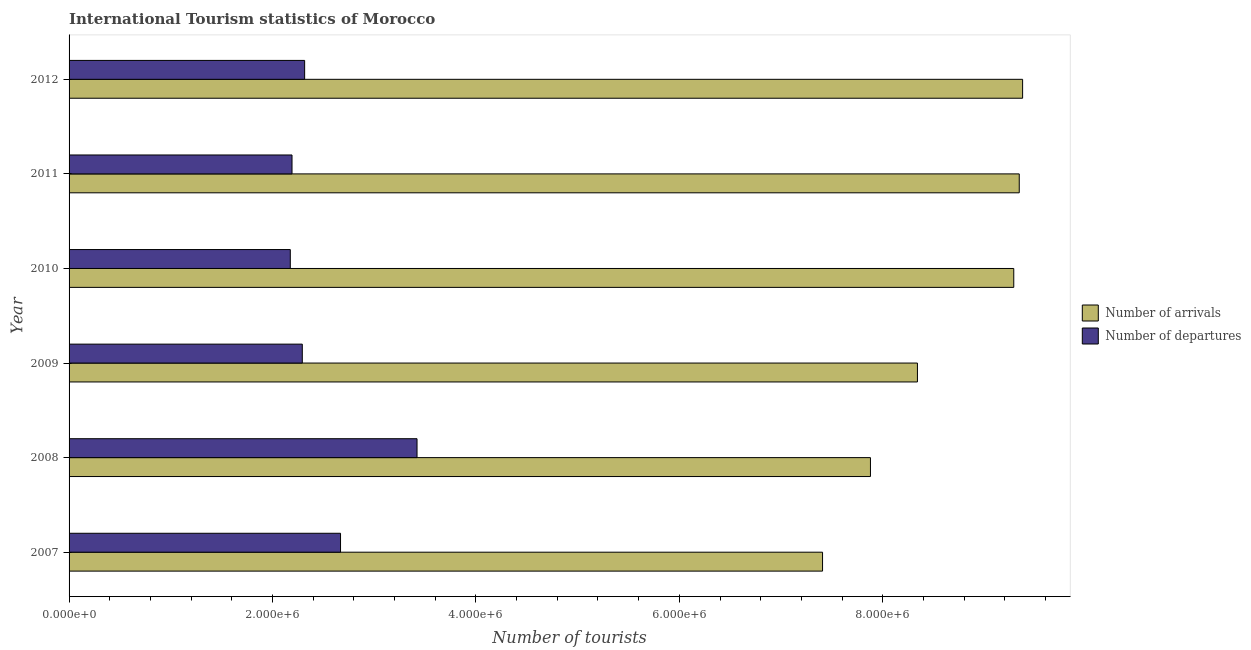How many different coloured bars are there?
Keep it short and to the point. 2. Are the number of bars per tick equal to the number of legend labels?
Your response must be concise. Yes. How many bars are there on the 1st tick from the top?
Your response must be concise. 2. How many bars are there on the 6th tick from the bottom?
Provide a succinct answer. 2. In how many cases, is the number of bars for a given year not equal to the number of legend labels?
Offer a terse response. 0. What is the number of tourist departures in 2012?
Your answer should be very brief. 2.32e+06. Across all years, what is the maximum number of tourist arrivals?
Ensure brevity in your answer.  9.38e+06. Across all years, what is the minimum number of tourist arrivals?
Your answer should be very brief. 7.41e+06. In which year was the number of tourist arrivals maximum?
Keep it short and to the point. 2012. In which year was the number of tourist departures minimum?
Your answer should be very brief. 2010. What is the total number of tourist arrivals in the graph?
Your answer should be compact. 5.16e+07. What is the difference between the number of tourist arrivals in 2009 and that in 2011?
Ensure brevity in your answer.  -1.00e+06. What is the difference between the number of tourist arrivals in 2007 and the number of tourist departures in 2012?
Offer a terse response. 5.09e+06. What is the average number of tourist arrivals per year?
Make the answer very short. 8.61e+06. In the year 2009, what is the difference between the number of tourist departures and number of tourist arrivals?
Give a very brief answer. -6.05e+06. What is the ratio of the number of tourist arrivals in 2010 to that in 2011?
Give a very brief answer. 0.99. What is the difference between the highest and the second highest number of tourist arrivals?
Your answer should be very brief. 3.30e+04. What is the difference between the highest and the lowest number of tourist departures?
Ensure brevity in your answer.  1.25e+06. What does the 1st bar from the top in 2011 represents?
Make the answer very short. Number of departures. What does the 2nd bar from the bottom in 2008 represents?
Ensure brevity in your answer.  Number of departures. How many bars are there?
Your answer should be very brief. 12. Are all the bars in the graph horizontal?
Give a very brief answer. Yes. How many years are there in the graph?
Provide a succinct answer. 6. What is the difference between two consecutive major ticks on the X-axis?
Your answer should be very brief. 2.00e+06. Are the values on the major ticks of X-axis written in scientific E-notation?
Ensure brevity in your answer.  Yes. Does the graph contain grids?
Provide a succinct answer. No. What is the title of the graph?
Offer a terse response. International Tourism statistics of Morocco. Does "Automatic Teller Machines" appear as one of the legend labels in the graph?
Your response must be concise. No. What is the label or title of the X-axis?
Keep it short and to the point. Number of tourists. What is the label or title of the Y-axis?
Your answer should be compact. Year. What is the Number of tourists in Number of arrivals in 2007?
Your answer should be very brief. 7.41e+06. What is the Number of tourists of Number of departures in 2007?
Make the answer very short. 2.67e+06. What is the Number of tourists in Number of arrivals in 2008?
Offer a very short reply. 7.88e+06. What is the Number of tourists in Number of departures in 2008?
Ensure brevity in your answer.  3.42e+06. What is the Number of tourists in Number of arrivals in 2009?
Give a very brief answer. 8.34e+06. What is the Number of tourists in Number of departures in 2009?
Offer a terse response. 2.29e+06. What is the Number of tourists in Number of arrivals in 2010?
Offer a terse response. 9.29e+06. What is the Number of tourists of Number of departures in 2010?
Your response must be concise. 2.18e+06. What is the Number of tourists of Number of arrivals in 2011?
Keep it short and to the point. 9.34e+06. What is the Number of tourists in Number of departures in 2011?
Provide a short and direct response. 2.19e+06. What is the Number of tourists in Number of arrivals in 2012?
Provide a short and direct response. 9.38e+06. What is the Number of tourists in Number of departures in 2012?
Keep it short and to the point. 2.32e+06. Across all years, what is the maximum Number of tourists of Number of arrivals?
Give a very brief answer. 9.38e+06. Across all years, what is the maximum Number of tourists of Number of departures?
Your response must be concise. 3.42e+06. Across all years, what is the minimum Number of tourists in Number of arrivals?
Keep it short and to the point. 7.41e+06. Across all years, what is the minimum Number of tourists of Number of departures?
Your answer should be very brief. 2.18e+06. What is the total Number of tourists in Number of arrivals in the graph?
Offer a very short reply. 5.16e+07. What is the total Number of tourists of Number of departures in the graph?
Keep it short and to the point. 1.51e+07. What is the difference between the Number of tourists of Number of arrivals in 2007 and that in 2008?
Your response must be concise. -4.71e+05. What is the difference between the Number of tourists in Number of departures in 2007 and that in 2008?
Make the answer very short. -7.52e+05. What is the difference between the Number of tourists in Number of arrivals in 2007 and that in 2009?
Make the answer very short. -9.33e+05. What is the difference between the Number of tourists of Number of departures in 2007 and that in 2009?
Offer a very short reply. 3.76e+05. What is the difference between the Number of tourists in Number of arrivals in 2007 and that in 2010?
Give a very brief answer. -1.88e+06. What is the difference between the Number of tourists of Number of departures in 2007 and that in 2010?
Give a very brief answer. 4.94e+05. What is the difference between the Number of tourists of Number of arrivals in 2007 and that in 2011?
Give a very brief answer. -1.93e+06. What is the difference between the Number of tourists in Number of departures in 2007 and that in 2011?
Your answer should be very brief. 4.77e+05. What is the difference between the Number of tourists in Number of arrivals in 2007 and that in 2012?
Provide a short and direct response. -1.97e+06. What is the difference between the Number of tourists of Number of departures in 2007 and that in 2012?
Ensure brevity in your answer.  3.53e+05. What is the difference between the Number of tourists in Number of arrivals in 2008 and that in 2009?
Provide a succinct answer. -4.62e+05. What is the difference between the Number of tourists in Number of departures in 2008 and that in 2009?
Your answer should be very brief. 1.13e+06. What is the difference between the Number of tourists of Number of arrivals in 2008 and that in 2010?
Ensure brevity in your answer.  -1.41e+06. What is the difference between the Number of tourists in Number of departures in 2008 and that in 2010?
Keep it short and to the point. 1.25e+06. What is the difference between the Number of tourists in Number of arrivals in 2008 and that in 2011?
Your response must be concise. -1.46e+06. What is the difference between the Number of tourists in Number of departures in 2008 and that in 2011?
Your answer should be compact. 1.23e+06. What is the difference between the Number of tourists of Number of arrivals in 2008 and that in 2012?
Offer a very short reply. -1.50e+06. What is the difference between the Number of tourists of Number of departures in 2008 and that in 2012?
Provide a succinct answer. 1.10e+06. What is the difference between the Number of tourists in Number of arrivals in 2009 and that in 2010?
Your answer should be compact. -9.47e+05. What is the difference between the Number of tourists of Number of departures in 2009 and that in 2010?
Make the answer very short. 1.18e+05. What is the difference between the Number of tourists of Number of arrivals in 2009 and that in 2011?
Make the answer very short. -1.00e+06. What is the difference between the Number of tourists in Number of departures in 2009 and that in 2011?
Offer a terse response. 1.01e+05. What is the difference between the Number of tourists in Number of arrivals in 2009 and that in 2012?
Your answer should be very brief. -1.03e+06. What is the difference between the Number of tourists in Number of departures in 2009 and that in 2012?
Your answer should be compact. -2.30e+04. What is the difference between the Number of tourists of Number of arrivals in 2010 and that in 2011?
Your answer should be compact. -5.40e+04. What is the difference between the Number of tourists in Number of departures in 2010 and that in 2011?
Your response must be concise. -1.70e+04. What is the difference between the Number of tourists of Number of arrivals in 2010 and that in 2012?
Make the answer very short. -8.70e+04. What is the difference between the Number of tourists of Number of departures in 2010 and that in 2012?
Provide a short and direct response. -1.41e+05. What is the difference between the Number of tourists in Number of arrivals in 2011 and that in 2012?
Give a very brief answer. -3.30e+04. What is the difference between the Number of tourists of Number of departures in 2011 and that in 2012?
Offer a very short reply. -1.24e+05. What is the difference between the Number of tourists in Number of arrivals in 2007 and the Number of tourists in Number of departures in 2008?
Offer a very short reply. 3.99e+06. What is the difference between the Number of tourists of Number of arrivals in 2007 and the Number of tourists of Number of departures in 2009?
Your response must be concise. 5.12e+06. What is the difference between the Number of tourists of Number of arrivals in 2007 and the Number of tourists of Number of departures in 2010?
Your response must be concise. 5.23e+06. What is the difference between the Number of tourists of Number of arrivals in 2007 and the Number of tourists of Number of departures in 2011?
Your answer should be compact. 5.22e+06. What is the difference between the Number of tourists of Number of arrivals in 2007 and the Number of tourists of Number of departures in 2012?
Offer a terse response. 5.09e+06. What is the difference between the Number of tourists in Number of arrivals in 2008 and the Number of tourists in Number of departures in 2009?
Your response must be concise. 5.59e+06. What is the difference between the Number of tourists in Number of arrivals in 2008 and the Number of tourists in Number of departures in 2010?
Make the answer very short. 5.70e+06. What is the difference between the Number of tourists in Number of arrivals in 2008 and the Number of tourists in Number of departures in 2011?
Your answer should be very brief. 5.69e+06. What is the difference between the Number of tourists in Number of arrivals in 2008 and the Number of tourists in Number of departures in 2012?
Your answer should be very brief. 5.56e+06. What is the difference between the Number of tourists in Number of arrivals in 2009 and the Number of tourists in Number of departures in 2010?
Your answer should be compact. 6.17e+06. What is the difference between the Number of tourists in Number of arrivals in 2009 and the Number of tourists in Number of departures in 2011?
Give a very brief answer. 6.15e+06. What is the difference between the Number of tourists in Number of arrivals in 2009 and the Number of tourists in Number of departures in 2012?
Give a very brief answer. 6.02e+06. What is the difference between the Number of tourists in Number of arrivals in 2010 and the Number of tourists in Number of departures in 2011?
Offer a very short reply. 7.10e+06. What is the difference between the Number of tourists in Number of arrivals in 2010 and the Number of tourists in Number of departures in 2012?
Offer a very short reply. 6.97e+06. What is the difference between the Number of tourists of Number of arrivals in 2011 and the Number of tourists of Number of departures in 2012?
Provide a succinct answer. 7.03e+06. What is the average Number of tourists of Number of arrivals per year?
Give a very brief answer. 8.61e+06. What is the average Number of tourists of Number of departures per year?
Your answer should be compact. 2.51e+06. In the year 2007, what is the difference between the Number of tourists in Number of arrivals and Number of tourists in Number of departures?
Ensure brevity in your answer.  4.74e+06. In the year 2008, what is the difference between the Number of tourists in Number of arrivals and Number of tourists in Number of departures?
Offer a very short reply. 4.46e+06. In the year 2009, what is the difference between the Number of tourists of Number of arrivals and Number of tourists of Number of departures?
Your answer should be compact. 6.05e+06. In the year 2010, what is the difference between the Number of tourists of Number of arrivals and Number of tourists of Number of departures?
Your answer should be compact. 7.11e+06. In the year 2011, what is the difference between the Number of tourists of Number of arrivals and Number of tourists of Number of departures?
Your answer should be compact. 7.15e+06. In the year 2012, what is the difference between the Number of tourists of Number of arrivals and Number of tourists of Number of departures?
Make the answer very short. 7.06e+06. What is the ratio of the Number of tourists of Number of arrivals in 2007 to that in 2008?
Offer a very short reply. 0.94. What is the ratio of the Number of tourists in Number of departures in 2007 to that in 2008?
Your response must be concise. 0.78. What is the ratio of the Number of tourists of Number of arrivals in 2007 to that in 2009?
Make the answer very short. 0.89. What is the ratio of the Number of tourists in Number of departures in 2007 to that in 2009?
Make the answer very short. 1.16. What is the ratio of the Number of tourists of Number of arrivals in 2007 to that in 2010?
Give a very brief answer. 0.8. What is the ratio of the Number of tourists in Number of departures in 2007 to that in 2010?
Provide a short and direct response. 1.23. What is the ratio of the Number of tourists of Number of arrivals in 2007 to that in 2011?
Offer a terse response. 0.79. What is the ratio of the Number of tourists of Number of departures in 2007 to that in 2011?
Your answer should be compact. 1.22. What is the ratio of the Number of tourists in Number of arrivals in 2007 to that in 2012?
Your response must be concise. 0.79. What is the ratio of the Number of tourists in Number of departures in 2007 to that in 2012?
Offer a terse response. 1.15. What is the ratio of the Number of tourists of Number of arrivals in 2008 to that in 2009?
Offer a terse response. 0.94. What is the ratio of the Number of tourists of Number of departures in 2008 to that in 2009?
Give a very brief answer. 1.49. What is the ratio of the Number of tourists in Number of arrivals in 2008 to that in 2010?
Offer a very short reply. 0.85. What is the ratio of the Number of tourists in Number of departures in 2008 to that in 2010?
Give a very brief answer. 1.57. What is the ratio of the Number of tourists of Number of arrivals in 2008 to that in 2011?
Provide a succinct answer. 0.84. What is the ratio of the Number of tourists of Number of departures in 2008 to that in 2011?
Your response must be concise. 1.56. What is the ratio of the Number of tourists of Number of arrivals in 2008 to that in 2012?
Provide a short and direct response. 0.84. What is the ratio of the Number of tourists of Number of departures in 2008 to that in 2012?
Your answer should be very brief. 1.48. What is the ratio of the Number of tourists in Number of arrivals in 2009 to that in 2010?
Offer a terse response. 0.9. What is the ratio of the Number of tourists in Number of departures in 2009 to that in 2010?
Offer a very short reply. 1.05. What is the ratio of the Number of tourists of Number of arrivals in 2009 to that in 2011?
Make the answer very short. 0.89. What is the ratio of the Number of tourists in Number of departures in 2009 to that in 2011?
Offer a very short reply. 1.05. What is the ratio of the Number of tourists of Number of arrivals in 2009 to that in 2012?
Offer a terse response. 0.89. What is the ratio of the Number of tourists of Number of departures in 2009 to that in 2012?
Ensure brevity in your answer.  0.99. What is the ratio of the Number of tourists of Number of departures in 2010 to that in 2011?
Provide a succinct answer. 0.99. What is the ratio of the Number of tourists in Number of arrivals in 2010 to that in 2012?
Your answer should be very brief. 0.99. What is the ratio of the Number of tourists of Number of departures in 2010 to that in 2012?
Your response must be concise. 0.94. What is the ratio of the Number of tourists in Number of departures in 2011 to that in 2012?
Give a very brief answer. 0.95. What is the difference between the highest and the second highest Number of tourists in Number of arrivals?
Provide a succinct answer. 3.30e+04. What is the difference between the highest and the second highest Number of tourists in Number of departures?
Offer a very short reply. 7.52e+05. What is the difference between the highest and the lowest Number of tourists of Number of arrivals?
Offer a terse response. 1.97e+06. What is the difference between the highest and the lowest Number of tourists of Number of departures?
Offer a terse response. 1.25e+06. 